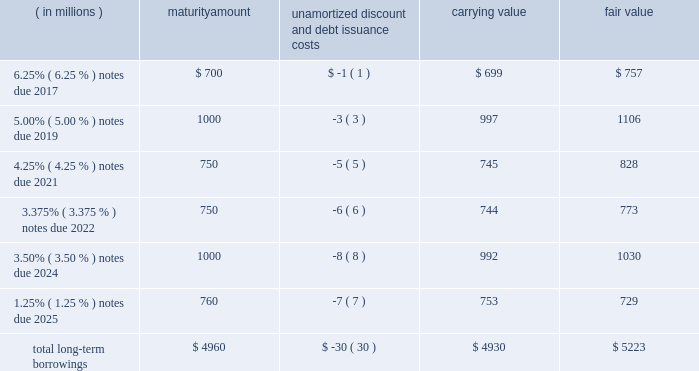12 .
Borrowings short-term borrowings 2015 revolving credit facility .
In march 2011 , the company entered into a five-year $ 3.5 billion unsecured revolving credit facility , which was amended in 2014 , 2013 and 2012 .
In april 2015 , the company 2019s credit facility was further amended to extend the maturity date to march 2020 and to increase the amount of the aggregate commitment to $ 4.0 billion ( the 201c2015 credit facility 201d ) .
The 2015 credit facility permits the company to request up to an additional $ 1.0 billion of borrowing capacity , subject to lender credit approval , increasing the overall size of the 2015 credit facility to an aggregate principal amount not to exceed $ 5.0 billion .
Interest on borrowings outstanding accrues at a rate based on the applicable london interbank offered rate plus a spread .
The 2015 credit facility requires the company not to exceed a maximum leverage ratio ( ratio of net debt to earnings before interest , taxes , depreciation and amortization , where net debt equals total debt less unrestricted cash ) of 3 to 1 , which was satisfied with a ratio of less than 1 to 1 at december 31 , 2015 .
The 2015 credit facility provides back-up liquidity to fund ongoing working capital for general corporate purposes and various investment opportunities .
At december 31 , 2015 , the company had no amount outstanding under the 2015 credit facility .
Commercial paper program .
On october 14 , 2009 , blackrock established a commercial paper program ( the 201ccp program 201d ) under which the company could issue unsecured commercial paper notes ( the 201ccp notes 201d ) on a private placement basis up to a maximum aggregate amount outstanding at any time of $ 4.0 billion as amended in april 2015 .
The cp program is currently supported by the 2015 credit facility .
At december 31 , 2015 , blackrock had no cp notes outstanding .
Long-term borrowings the carrying value and fair value of long-term borrowings estimated using market prices and foreign exchange rates at december 31 , 2015 included the following : ( in millions ) maturity amount unamortized discount and debt issuance costs carrying value fair value .
Long-term borrowings at december 31 , 2014 had a carrying value of $ 4.922 billion and a fair value of $ 5.309 billion determined using market prices at the end of december 2025 notes .
In may 2015 , the company issued 20ac700 million of 1.25% ( 1.25 % ) senior unsecured notes maturing on may 6 , 2025 ( the 201c2025 notes 201d ) .
The notes are listed on the new york stock exchange .
The net proceeds of the 2025 notes were used for general corporate purposes , including refinancing of outstanding indebtedness .
Interest of approximately $ 10 million per year based on current exchange rates is payable annually on may 6 of each year .
The 2025 notes may be redeemed in whole or in part prior to maturity at any time at the option of the company at a 201cmake-whole 201d redemption price .
The unamortized discount and debt issuance costs are being amortized over the remaining term of the 2025 notes .
Upon conversion to u.s .
Dollars the company designated the 20ac700 million debt offering as a net investment hedge to offset its currency exposure relating to its net investment in certain euro functional currency operations .
A gain of $ 19 million , net of tax , was recognized in other comprehensive income for 2015 .
No hedge ineffectiveness was recognized during 2015 .
2024 notes .
In march 2014 , the company issued $ 1.0 billion in aggregate principal amount of 3.50% ( 3.50 % ) senior unsecured and unsubordinated notes maturing on march 18 , 2024 ( the 201c2024 notes 201d ) .
The net proceeds of the 2024 notes were used to refinance certain indebtedness which matured in the fourth quarter of 2014 .
Interest is payable semi-annually in arrears on march 18 and september 18 of each year , or approximately $ 35 million per year .
The 2024 notes may be redeemed prior to maturity at any time in whole or in part at the option of the company at a 201cmake-whole 201d redemption price .
The unamortized discount and debt issuance costs are being amortized over the remaining term of the 2024 notes .
2022 notes .
In may 2012 , the company issued $ 1.5 billion in aggregate principal amount of unsecured unsubordinated obligations .
These notes were issued as two separate series of senior debt securities , including $ 750 million of 1.375% ( 1.375 % ) notes , which were repaid in june 2015 at maturity , and $ 750 million of 3.375% ( 3.375 % ) notes maturing in june 2022 ( the 201c2022 notes 201d ) .
Net proceeds were used to fund the repurchase of blackrock 2019s common stock and series b preferred from barclays and affiliates and for general corporate purposes .
Interest on the 2022 notes of approximately $ 25 million per year , respectively , is payable semi-annually on june 1 and december 1 of each year , which commenced december 1 , 2012 .
The 2022 notes may be redeemed prior to maturity at any time in whole or in part at the option of the company at a 201cmake-whole 201d redemption price .
The 201cmake-whole 201d redemption price represents a price , subject to the specific terms of the 2022 notes and related indenture , that is the greater of ( a ) par value and ( b ) the present value of future payments that will not be paid because of an early redemption , which is discounted at a fixed spread over a .
What percent of the fair value is in the carrying value? 
Computations: (4930 / 5223)
Answer: 0.9439. 